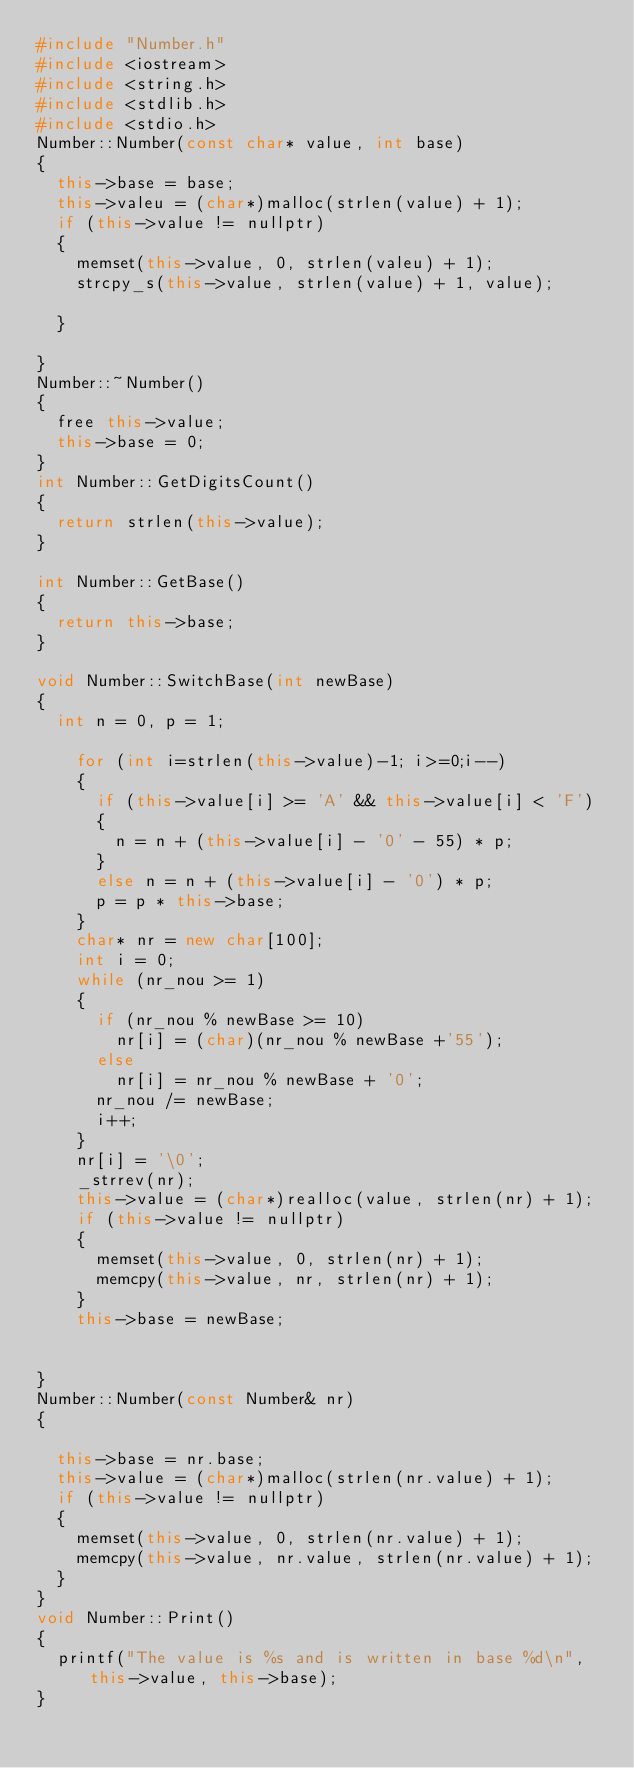<code> <loc_0><loc_0><loc_500><loc_500><_C++_>#include "Number.h"
#include <iostream>
#include <string.h>
#include <stdlib.h>
#include <stdio.h>
Number::Number(const char* value, int base)
{
	this->base = base;
	this->valeu = (char*)malloc(strlen(value) + 1);
	if (this->value != nullptr)
	{
		memset(this->value, 0, strlen(valeu) + 1);
		strcpy_s(this->value, strlen(value) + 1, value);

	}
	 
}
Number::~Number()
{
	free this->value;
	this->base = 0;
}
int Number::GetDigitsCount()
{
	return strlen(this->value);
}

int Number::GetBase()
{
	return this->base;
}

void Number::SwitchBase(int newBase)
{
	int n = 0, p = 1;
	
		for (int i=strlen(this->value)-1; i>=0;i--)
		{
			if (this->value[i] >= 'A' && this->value[i] < 'F')
			{
				n = n + (this->value[i] - '0' - 55) * p;
			}
			else n = n + (this->value[i] - '0') * p;
			p = p * this->base;
		}
		char* nr = new char[100];
		int i = 0;
		while (nr_nou >= 1)
		{
			if (nr_nou % newBase >= 10)
				nr[i] = (char)(nr_nou % newBase +'55');
			else
				nr[i] = nr_nou % newBase + '0';
			nr_nou /= newBase;
			i++;
		}
		nr[i] = '\0';
		_strrev(nr);
		this->value = (char*)realloc(value, strlen(nr) + 1);
		if (this->value != nullptr)
		{
			memset(this->value, 0, strlen(nr) + 1);
			memcpy(this->value, nr, strlen(nr) + 1);
		}
		this->base = newBase;


}
Number::Number(const Number& nr)
{

	this->base = nr.base;
	this->value = (char*)malloc(strlen(nr.value) + 1);
	if (this->value != nullptr)
	{
		memset(this->value, 0, strlen(nr.value) + 1);
		memcpy(this->value, nr.value, strlen(nr.value) + 1);
	}
}
void Number::Print()
{
	printf("The value is %s and is written in base %d\n", this->value, this->base);
}</code> 